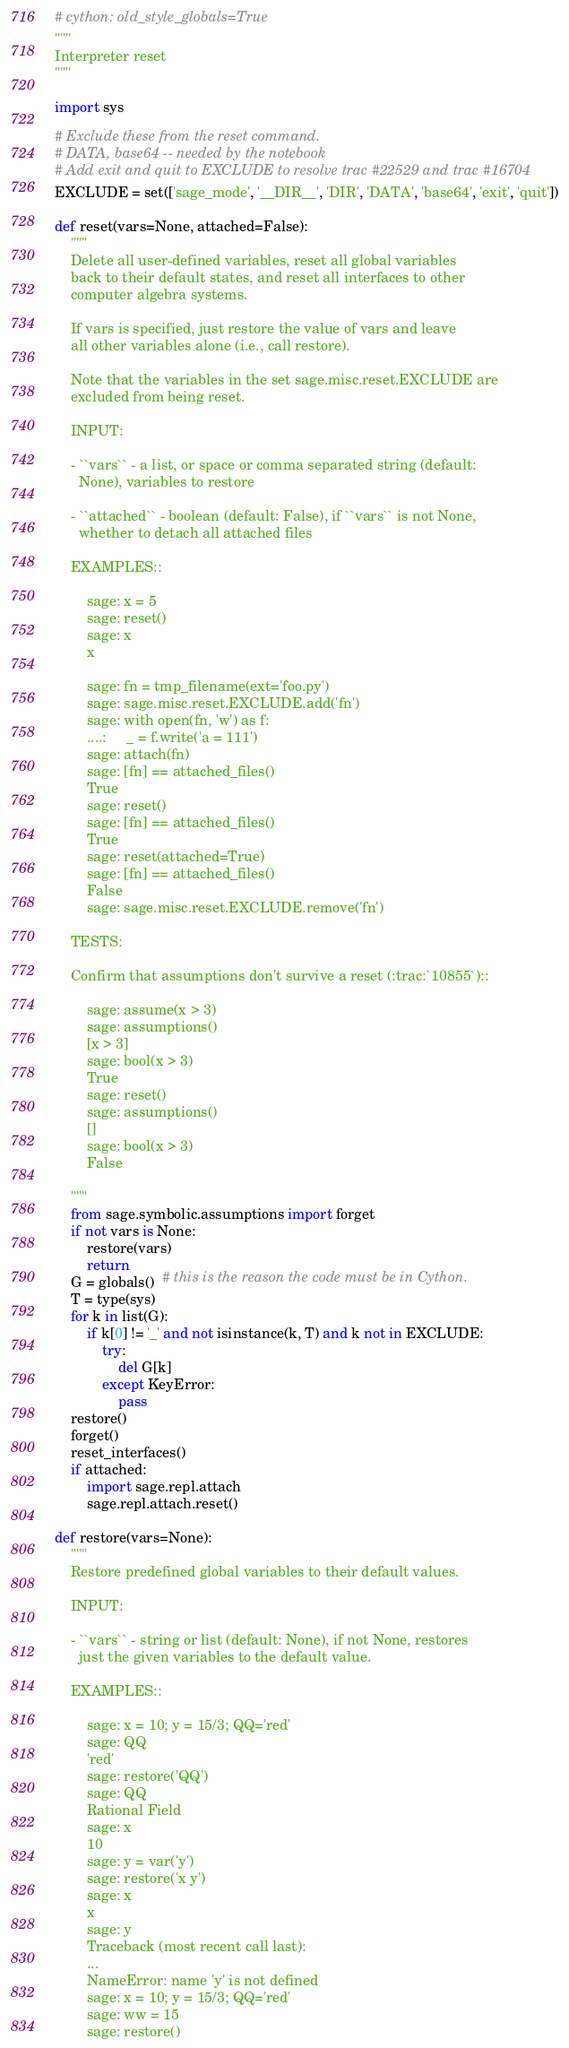<code> <loc_0><loc_0><loc_500><loc_500><_Cython_># cython: old_style_globals=True
"""
Interpreter reset
"""

import sys

# Exclude these from the reset command.
# DATA, base64 -- needed by the notebook
# Add exit and quit to EXCLUDE to resolve trac #22529 and trac #16704
EXCLUDE = set(['sage_mode', '__DIR__', 'DIR', 'DATA', 'base64', 'exit', 'quit'])

def reset(vars=None, attached=False):
    """
    Delete all user-defined variables, reset all global variables
    back to their default states, and reset all interfaces to other
    computer algebra systems.

    If vars is specified, just restore the value of vars and leave
    all other variables alone (i.e., call restore).

    Note that the variables in the set sage.misc.reset.EXCLUDE are
    excluded from being reset.

    INPUT:

    - ``vars`` - a list, or space or comma separated string (default:
      None), variables to restore

    - ``attached`` - boolean (default: False), if ``vars`` is not None,
      whether to detach all attached files

    EXAMPLES::

        sage: x = 5
        sage: reset()
        sage: x
        x

        sage: fn = tmp_filename(ext='foo.py')
        sage: sage.misc.reset.EXCLUDE.add('fn')
        sage: with open(fn, 'w') as f:
        ....:     _ = f.write('a = 111')
        sage: attach(fn)
        sage: [fn] == attached_files()
        True
        sage: reset()
        sage: [fn] == attached_files()
        True
        sage: reset(attached=True)
        sage: [fn] == attached_files()
        False
        sage: sage.misc.reset.EXCLUDE.remove('fn')

    TESTS:

    Confirm that assumptions don't survive a reset (:trac:`10855`)::

        sage: assume(x > 3)
        sage: assumptions()
        [x > 3]
        sage: bool(x > 3)
        True
        sage: reset()
        sage: assumptions()
        []
        sage: bool(x > 3)
        False

    """
    from sage.symbolic.assumptions import forget
    if not vars is None:
        restore(vars)
        return
    G = globals()  # this is the reason the code must be in Cython.
    T = type(sys)
    for k in list(G):
        if k[0] != '_' and not isinstance(k, T) and k not in EXCLUDE:
            try:
                del G[k]
            except KeyError:
                pass
    restore()
    forget()
    reset_interfaces()
    if attached:
        import sage.repl.attach
        sage.repl.attach.reset()

def restore(vars=None):
    """
    Restore predefined global variables to their default values.

    INPUT:

    - ``vars`` - string or list (default: None), if not None, restores
      just the given variables to the default value.

    EXAMPLES::

        sage: x = 10; y = 15/3; QQ='red'
        sage: QQ
        'red'
        sage: restore('QQ')
        sage: QQ
        Rational Field
        sage: x
        10
        sage: y = var('y')
        sage: restore('x y')
        sage: x
        x
        sage: y
        Traceback (most recent call last):
        ...
        NameError: name 'y' is not defined
        sage: x = 10; y = 15/3; QQ='red'
        sage: ww = 15
        sage: restore()</code> 